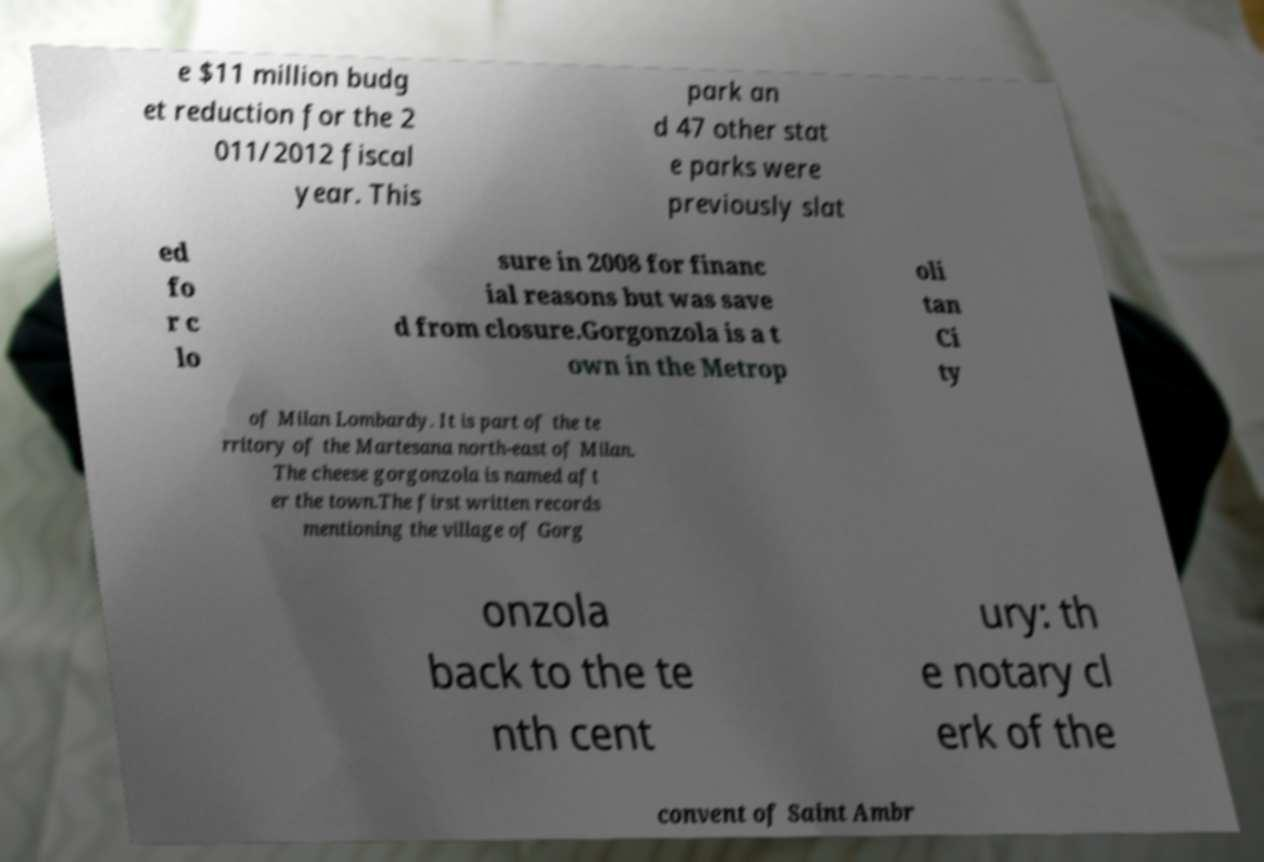There's text embedded in this image that I need extracted. Can you transcribe it verbatim? e $11 million budg et reduction for the 2 011/2012 fiscal year. This park an d 47 other stat e parks were previously slat ed fo r c lo sure in 2008 for financ ial reasons but was save d from closure.Gorgonzola is a t own in the Metrop oli tan Ci ty of Milan Lombardy. It is part of the te rritory of the Martesana north-east of Milan. The cheese gorgonzola is named aft er the town.The first written records mentioning the village of Gorg onzola back to the te nth cent ury: th e notary cl erk of the convent of Saint Ambr 